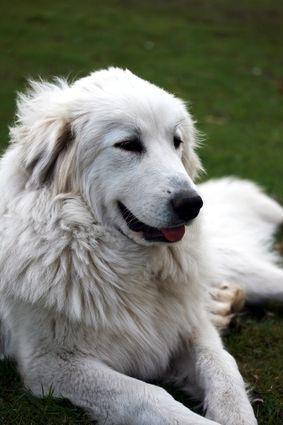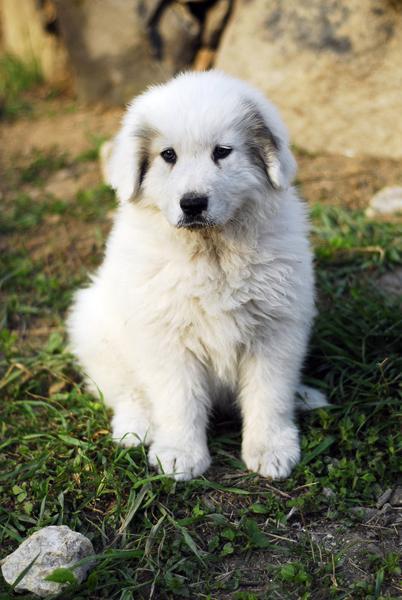The first image is the image on the left, the second image is the image on the right. Assess this claim about the two images: "A young puppy is lying down in one of the images.". Correct or not? Answer yes or no. No. The first image is the image on the left, the second image is the image on the right. Evaluate the accuracy of this statement regarding the images: "a dog is laying in the grass in the left image". Is it true? Answer yes or no. Yes. 